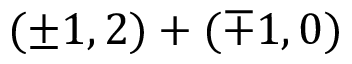<formula> <loc_0><loc_0><loc_500><loc_500>( \pm 1 , 2 ) + ( \mp 1 , 0 )</formula> 